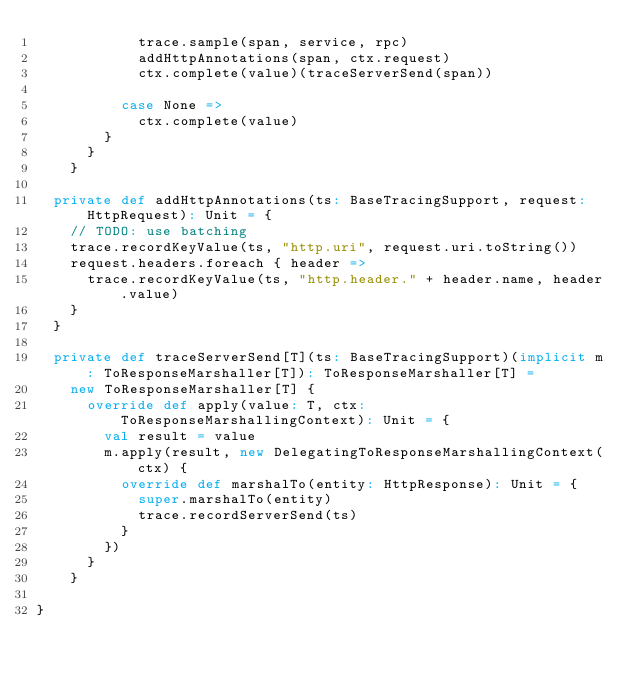<code> <loc_0><loc_0><loc_500><loc_500><_Scala_>            trace.sample(span, service, rpc)
            addHttpAnnotations(span, ctx.request)
            ctx.complete(value)(traceServerSend(span))

          case None =>
            ctx.complete(value)
        }
      }
    }

  private def addHttpAnnotations(ts: BaseTracingSupport, request: HttpRequest): Unit = {
    // TODO: use batching
    trace.recordKeyValue(ts, "http.uri", request.uri.toString())
    request.headers.foreach { header =>
      trace.recordKeyValue(ts, "http.header." + header.name, header.value)
    }
  }

  private def traceServerSend[T](ts: BaseTracingSupport)(implicit m: ToResponseMarshaller[T]): ToResponseMarshaller[T] =
    new ToResponseMarshaller[T] {
      override def apply(value: T, ctx: ToResponseMarshallingContext): Unit = {
        val result = value
        m.apply(result, new DelegatingToResponseMarshallingContext(ctx) {
          override def marshalTo(entity: HttpResponse): Unit = {
            super.marshalTo(entity)
            trace.recordServerSend(ts)
          }
        })
      }
    }

}

</code> 